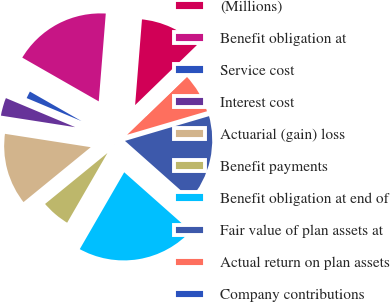<chart> <loc_0><loc_0><loc_500><loc_500><pie_chart><fcel>(Millions)<fcel>Benefit obligation at<fcel>Service cost<fcel>Interest cost<fcel>Actuarial (gain) loss<fcel>Benefit payments<fcel>Benefit obligation at end of<fcel>Fair value of plan assets at<fcel>Actual return on plan assets<fcel>Company contributions<nl><fcel>11.46%<fcel>18.0%<fcel>1.95%<fcel>3.86%<fcel>13.36%<fcel>5.76%<fcel>21.8%<fcel>16.1%<fcel>7.66%<fcel>0.05%<nl></chart> 